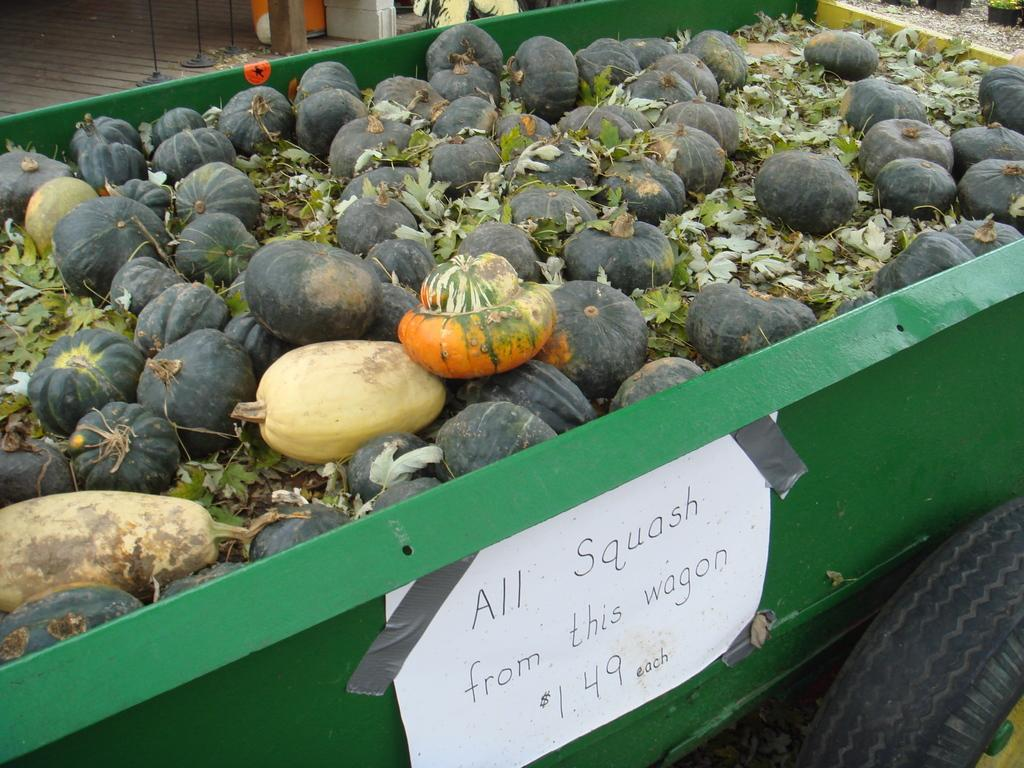What objects are present in the image? There are pumpkins in the image. How are the pumpkins being transported? The pumpkins are loaded in a truck. Is there any additional information about the truck? Yes, there is a label attached to the truck. Reasoning: Let' Let's think step by step in order to produce the conversation. We start by identifying the main subject in the image, which is the pumpkins. Then, we expand the conversation to include how the pumpkins are being transported, which is in a truck. Finally, we mention the label attached to the truck as an additional detail. Each question is designed to elicit a specific detail about the image that is known from the provided facts. Absurd Question/Answer: What type of stew is being prepared in the image? There is no stew present in the image; it features pumpkins loaded in a truck. Can you see any brothers in the image? There is no mention of brothers or any people in the image; it only shows pumpkins loaded in a truck. How many times did the brothers kick the pumpkins before loading them into the truck? There is no mention of brothers or any people in the image, and the pumpkins are already loaded into the truck. Therefore, it is not possible to answer this question based on the information provided. 